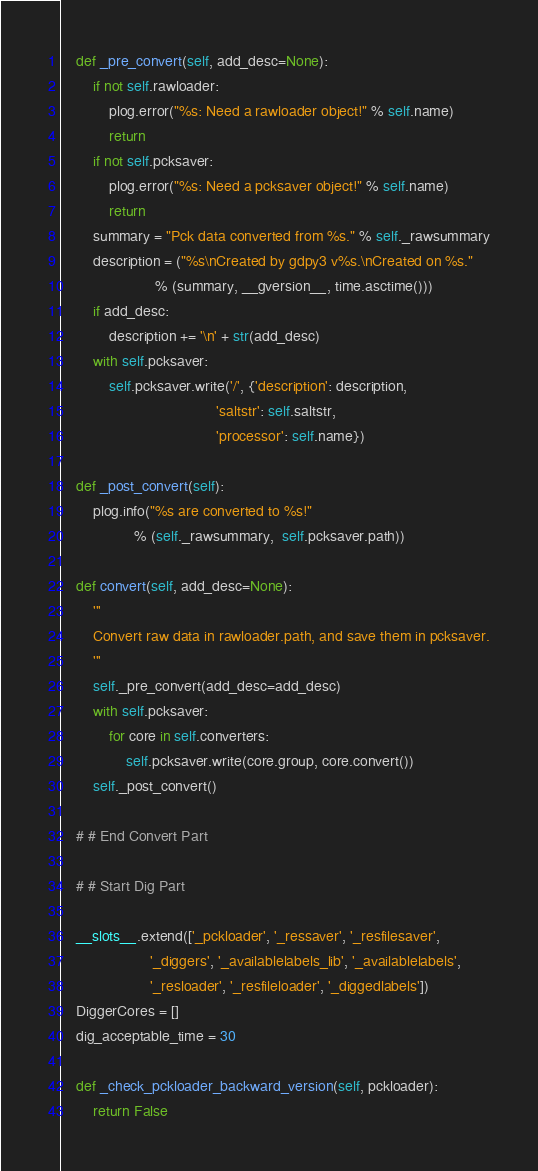<code> <loc_0><loc_0><loc_500><loc_500><_Python_>
    def _pre_convert(self, add_desc=None):
        if not self.rawloader:
            plog.error("%s: Need a rawloader object!" % self.name)
            return
        if not self.pcksaver:
            plog.error("%s: Need a pcksaver object!" % self.name)
            return
        summary = "Pck data converted from %s." % self._rawsummary
        description = ("%s\nCreated by gdpy3 v%s.\nCreated on %s."
                       % (summary, __gversion__, time.asctime()))
        if add_desc:
            description += '\n' + str(add_desc)
        with self.pcksaver:
            self.pcksaver.write('/', {'description': description,
                                      'saltstr': self.saltstr,
                                      'processor': self.name})

    def _post_convert(self):
        plog.info("%s are converted to %s!"
                  % (self._rawsummary,  self.pcksaver.path))

    def convert(self, add_desc=None):
        '''
        Convert raw data in rawloader.path, and save them in pcksaver.
        '''
        self._pre_convert(add_desc=add_desc)
        with self.pcksaver:
            for core in self.converters:
                self.pcksaver.write(core.group, core.convert())
        self._post_convert()

    # # End Convert Part

    # # Start Dig Part

    __slots__.extend(['_pckloader', '_ressaver', '_resfilesaver',
                      '_diggers', '_availablelabels_lib', '_availablelabels',
                      '_resloader', '_resfileloader', '_diggedlabels'])
    DiggerCores = []
    dig_acceptable_time = 30

    def _check_pckloader_backward_version(self, pckloader):
        return False
</code> 